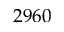Convert formula to latex. <formula><loc_0><loc_0><loc_500><loc_500>2 9 6 0</formula> 